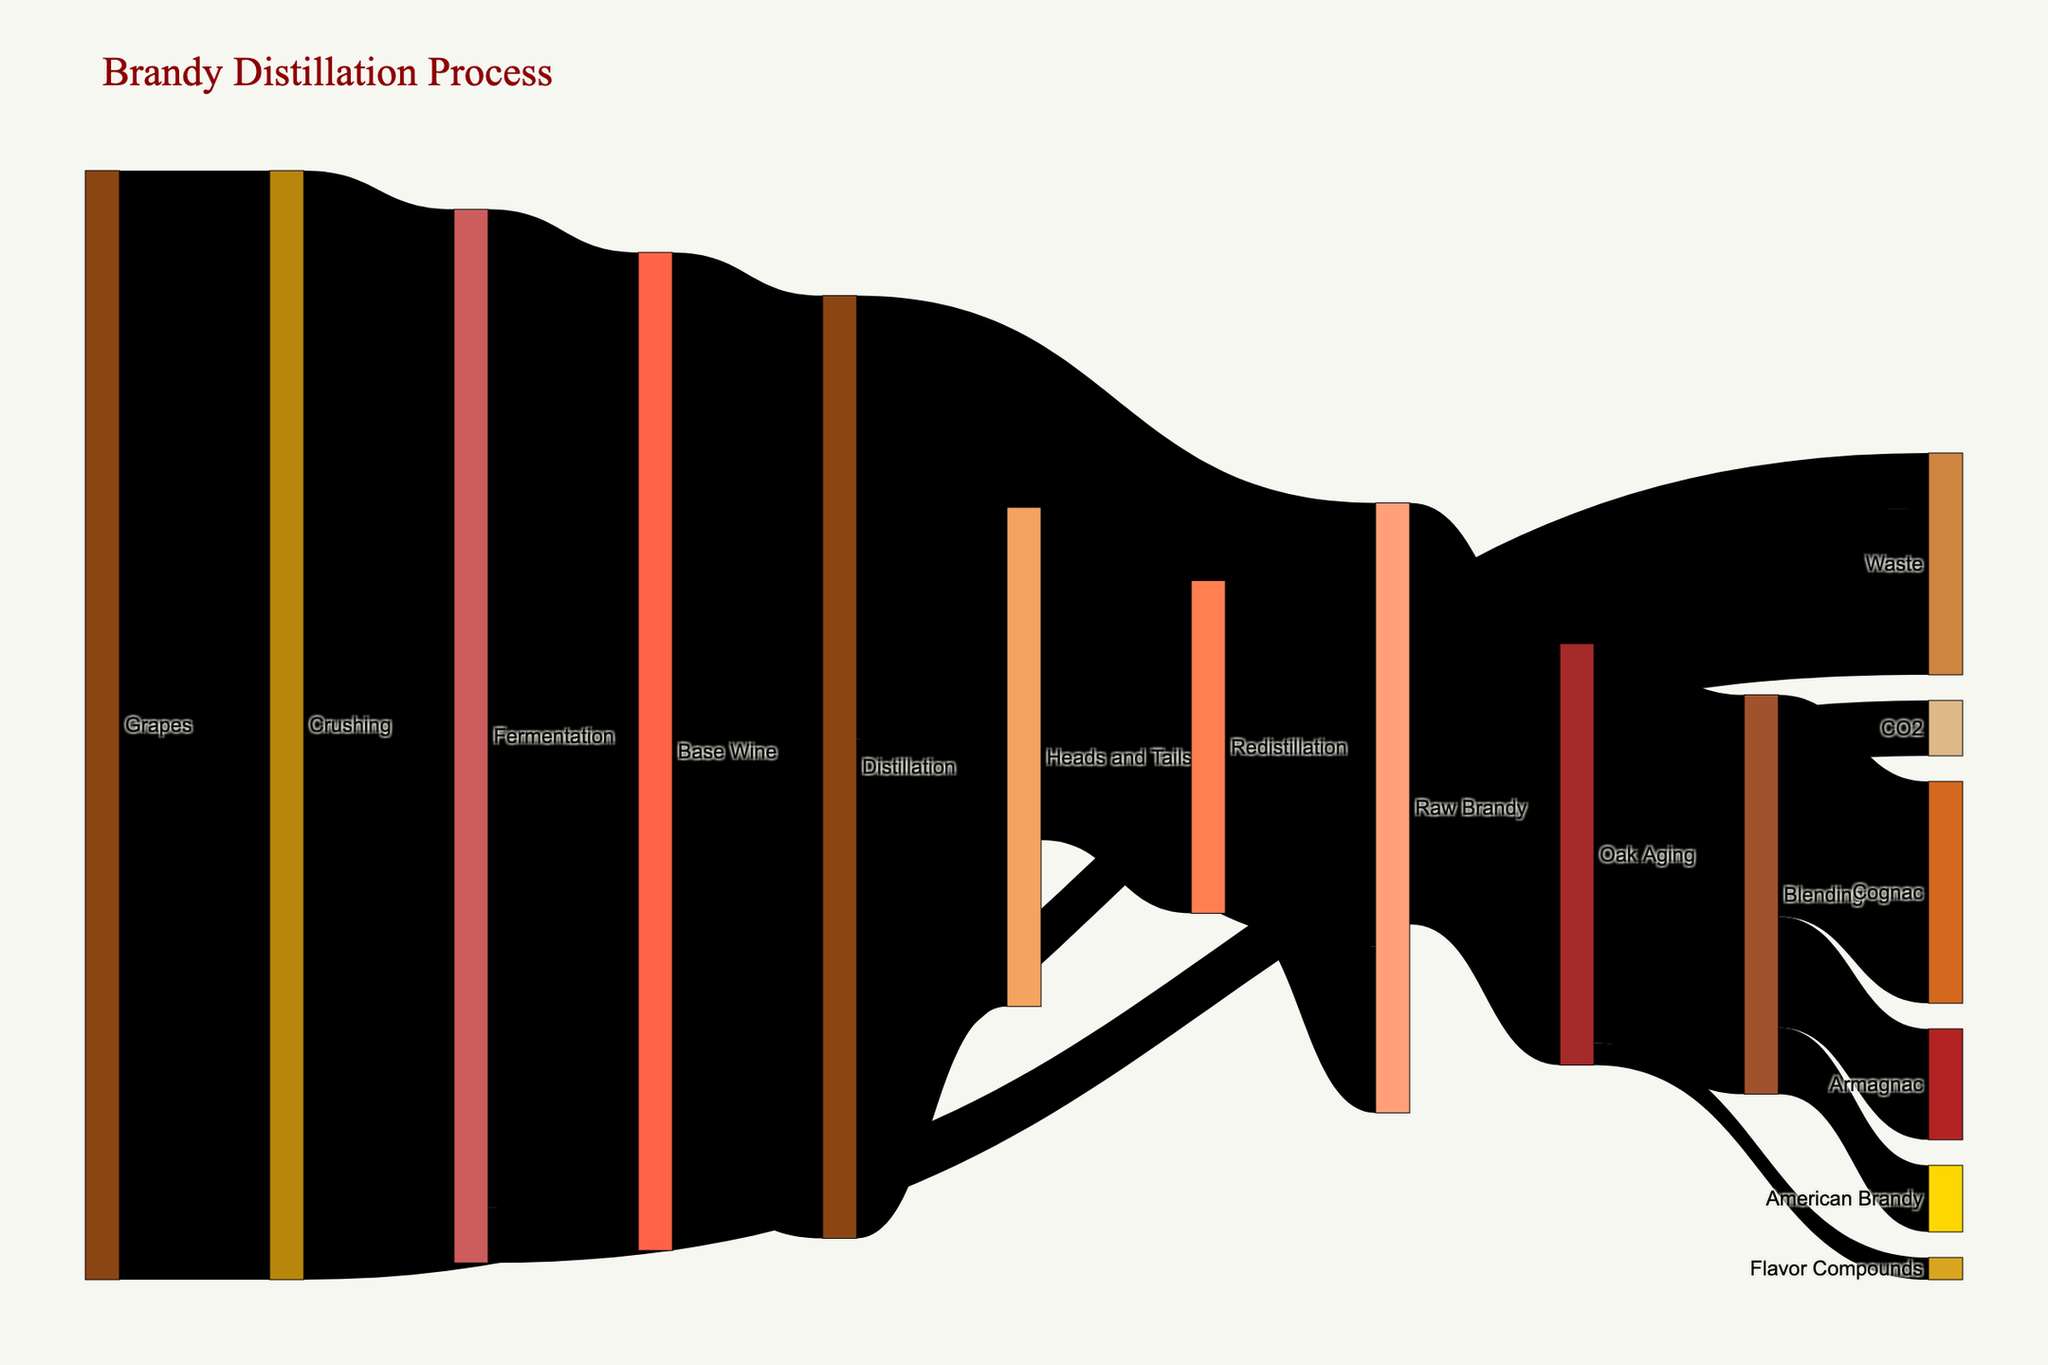What is the title of the Sankey Diagram? The title of a figure is usually displayed at the top of the visual representation. In this Sankey Diagram, the title is clearly stated as "Brandy Distillation Process".
Answer: Brandy Distillation Process How many main processes are depicted from Grapes to Cognac? The main processes can be identified by following the flow from Grapes to Cognac. The stages are: Grapes → Crushing → Fermentation → Base Wine → Distillation → Raw Brandy → Oak Aging → Blending → Cognac, which totals to 8 stages.
Answer: 8 What is the initial quantity of Grapes used in the process? The initial quantity is mentioned at the first stage where Grapes flow into. The value from Grapes to Crushing is 100, indicating the initial quantity.
Answer: 100 What percentage of the initial quantity of Grapes turns into Raw Brandy after Distillation? The initial quantity of Grapes is 100. The amount of Raw Brandy after Distillation is 40. The percentage is calculated as (40/100) * 100 = 40%.
Answer: 40% What is the transformation yield from Base Wine to Distillation? The value transitioning from Base Wine to Distillation is 85. The quantity of Base Wine is 90. The yield is calculated as 85/90 * 100 = 94.44%.
Answer: 94.44% Which product has higher final quantity, Cognac or Armagnac? The final quantity can be checked at the end stages. Cognac has a value of 20 and Armagnac has a value of 10. Cognac has the higher final quantity.
Answer: Cognac What is the total amount of waste produced in the entire process? Waste occurs at two stages: Crushing to Waste (5) and Redistillation to Waste (15). Adding them up gives 5 + 15 = 20.
Answer: 20 How much Raw Brandy is produced after Redistillation? From the Redistillation stage, there are 15 units leading to Raw Brandy.
Answer: 15 Which stages lead directly to Oak Aging? The diagram shows that Oak Aging is directly preceded by Raw Brandy and Oak Aging also has some input for Flavor Compounds. Therefore, Raw Brandy and some input flow named Oak Aging itself lead to Oak Aging.
Answer: Raw Brandy, Oak Aging (for Flavor Compounds) What are the proportions of Cognac, Armagnac, and American Brandy produced after Blending? The units for each produced are Cognac (20), Armagnac (10), and American Brandy (6). The proportions are calculated by the total from Blending (20 + 10 + 6 = 36). Cognac = 20/36, Armagnac = 10/36, American Brandy = 6/36, simplified these are about 55.56%, 27.78%, and 16.67% respectively.
Answer: Cognac: 55.56%, Armagnac: 27.78%, American Brandy: 16.67% 